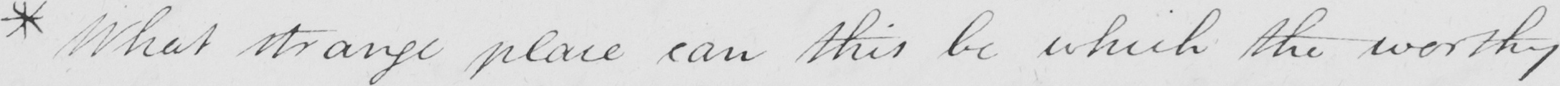What does this handwritten line say? * What strange place can this be which the worthy 